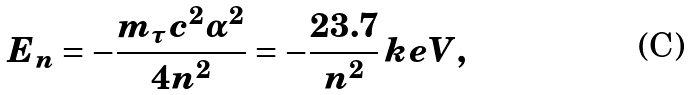<formula> <loc_0><loc_0><loc_500><loc_500>E _ { n } = - \frac { m _ { \tau } c ^ { 2 } \alpha ^ { 2 } } { 4 n ^ { 2 } } = - \frac { 2 3 . 7 } { n ^ { 2 } } \, k e V ,</formula> 